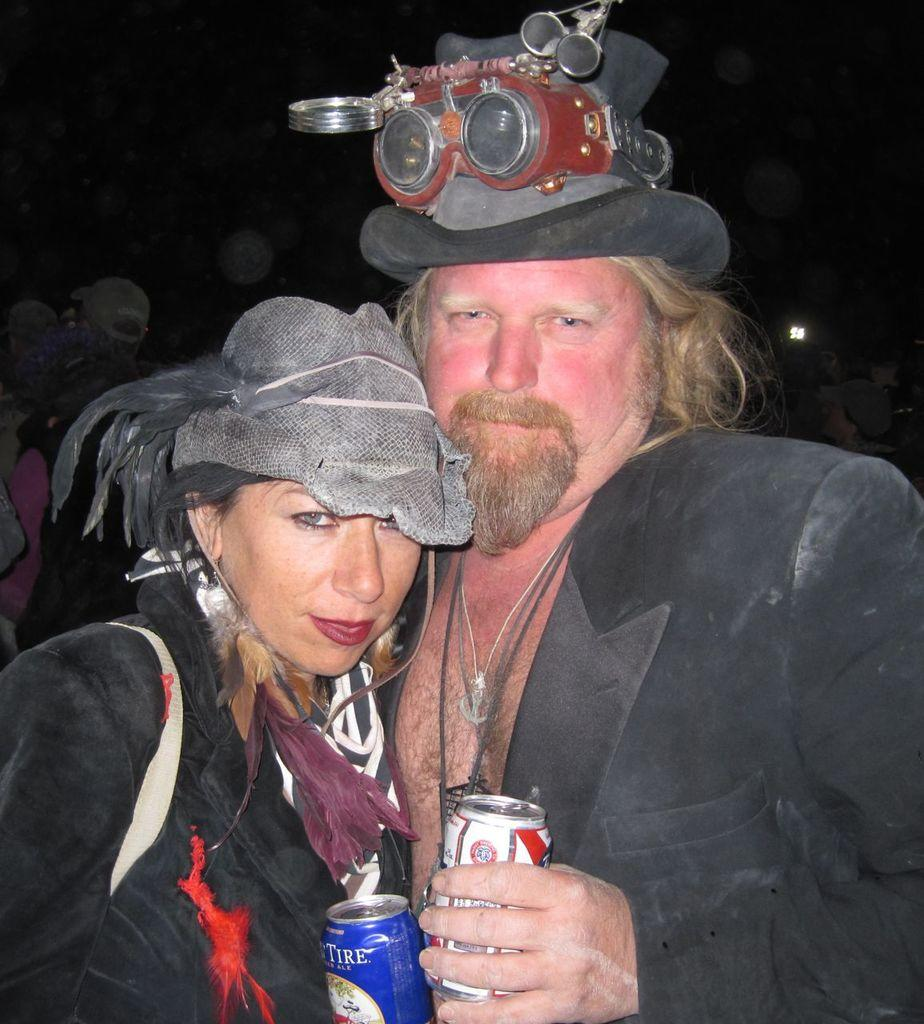How many people are in the image? There are two persons in the image. What color are the dresses worn by the persons in the image? Both persons are wearing black color dresses. What headgear are the persons wearing in the image? Both persons are wearing hats. What are the persons holding in their hands in the image? They are holding coke tins in their hands. What action are the two persons performing in the image? The two persons are hugging each other. Can you tell me how many rats are sitting on the coke tins in the image? There are no rats present in the image; it only features two persons hugging each other and holding coke tins. What type of ball is being used by the persons in the image? There is no ball present in the image; the persons are holding coke tins and hugging each other. 